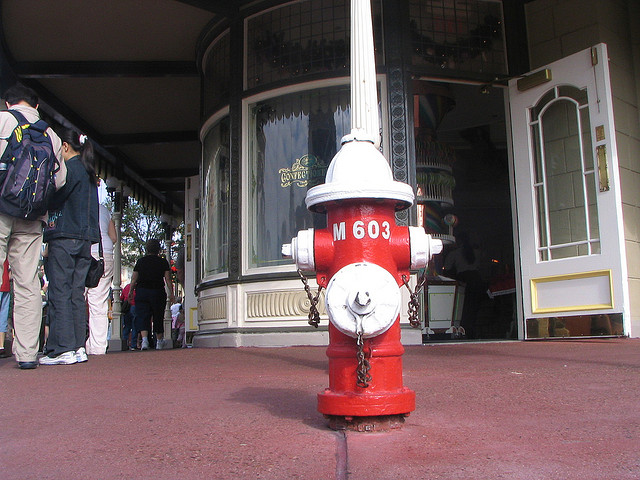<image>What kind of store is behind the hydrant? I am not sure about the kind of store behind the hydrant. It might be a boutique, clothing, sweets, jewelry, restaurant, candy, or wedding dress store. What kind of store is behind the hydrant? I am not sure what kind of store is behind the hydrant. It can be a boutique, a clothing store, a sweets shop, a jewelry store, or a restaurant. 